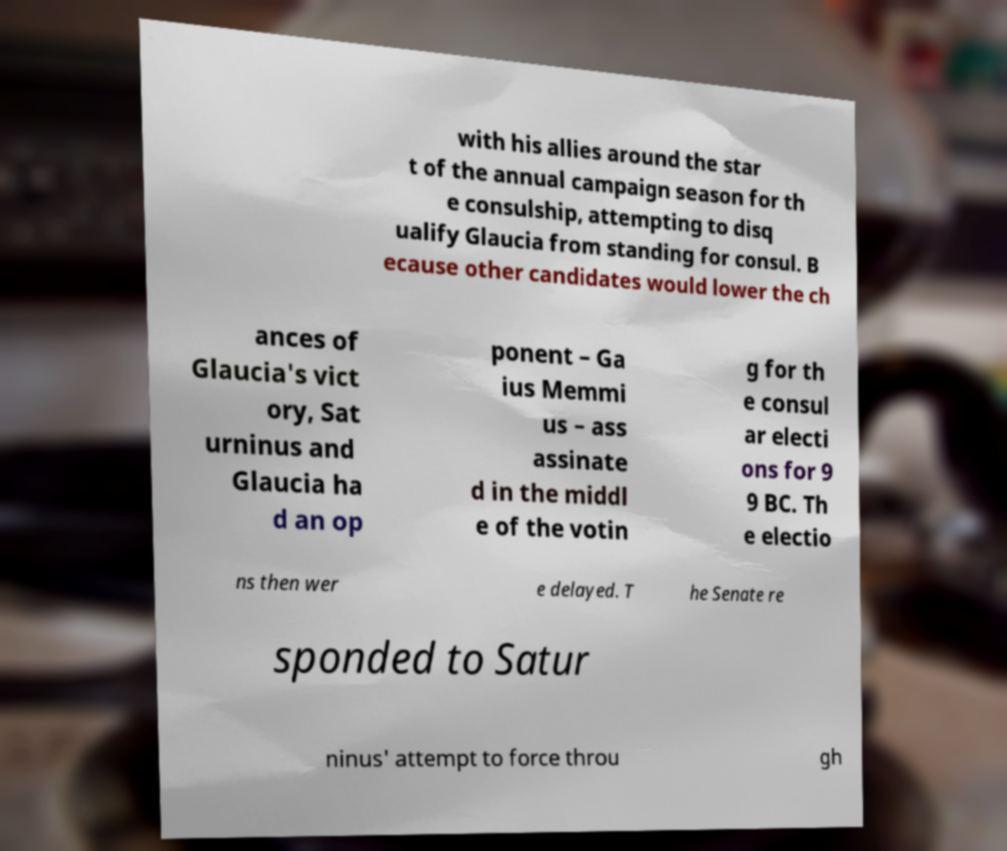Could you assist in decoding the text presented in this image and type it out clearly? with his allies around the star t of the annual campaign season for th e consulship, attempting to disq ualify Glaucia from standing for consul. B ecause other candidates would lower the ch ances of Glaucia's vict ory, Sat urninus and Glaucia ha d an op ponent – Ga ius Memmi us – ass assinate d in the middl e of the votin g for th e consul ar electi ons for 9 9 BC. Th e electio ns then wer e delayed. T he Senate re sponded to Satur ninus' attempt to force throu gh 